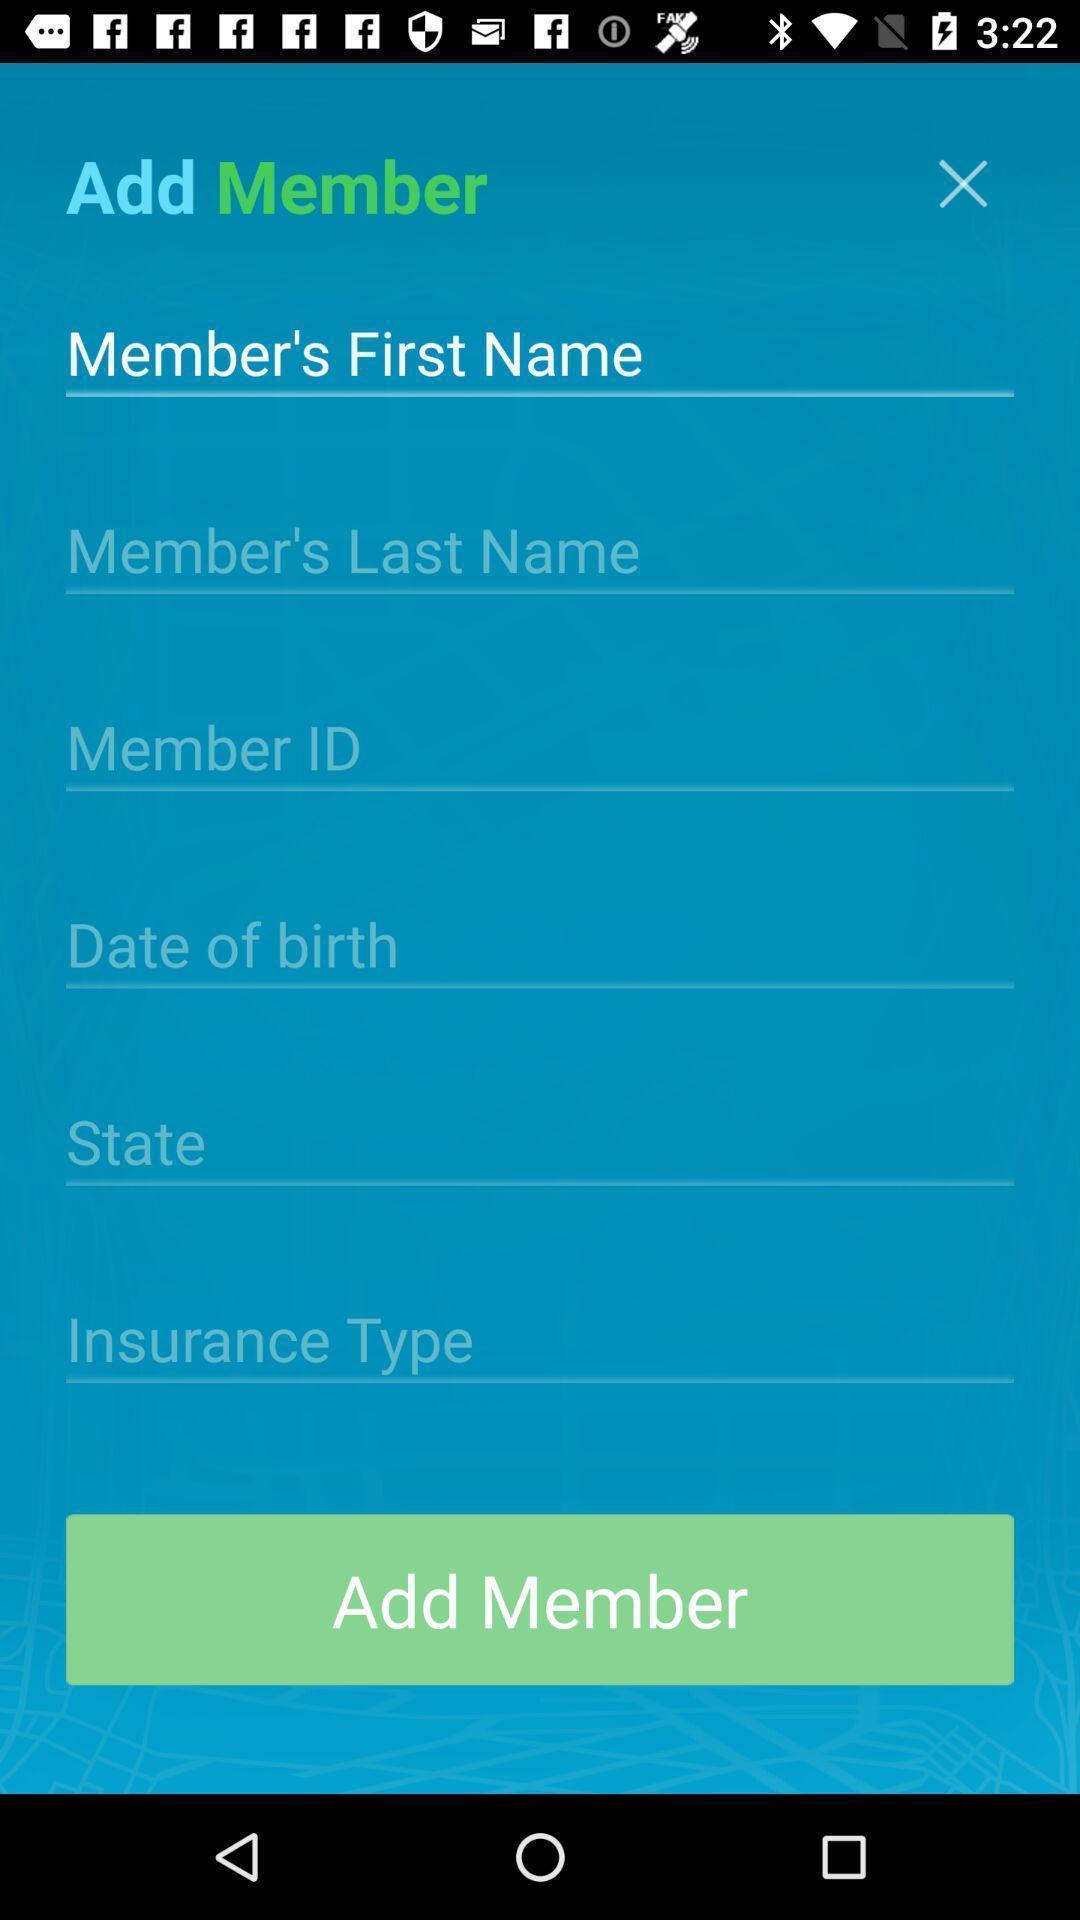Provide a detailed account of this screenshot. Screen showing add member page of a travel app. 